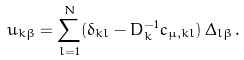Convert formula to latex. <formula><loc_0><loc_0><loc_500><loc_500>u _ { k \beta } = \sum _ { l = 1 } ^ { N } ( \delta _ { k l } - D _ { k } ^ { - 1 } c _ { \mu , k l } ) \, \Delta _ { l \beta } \, .</formula> 